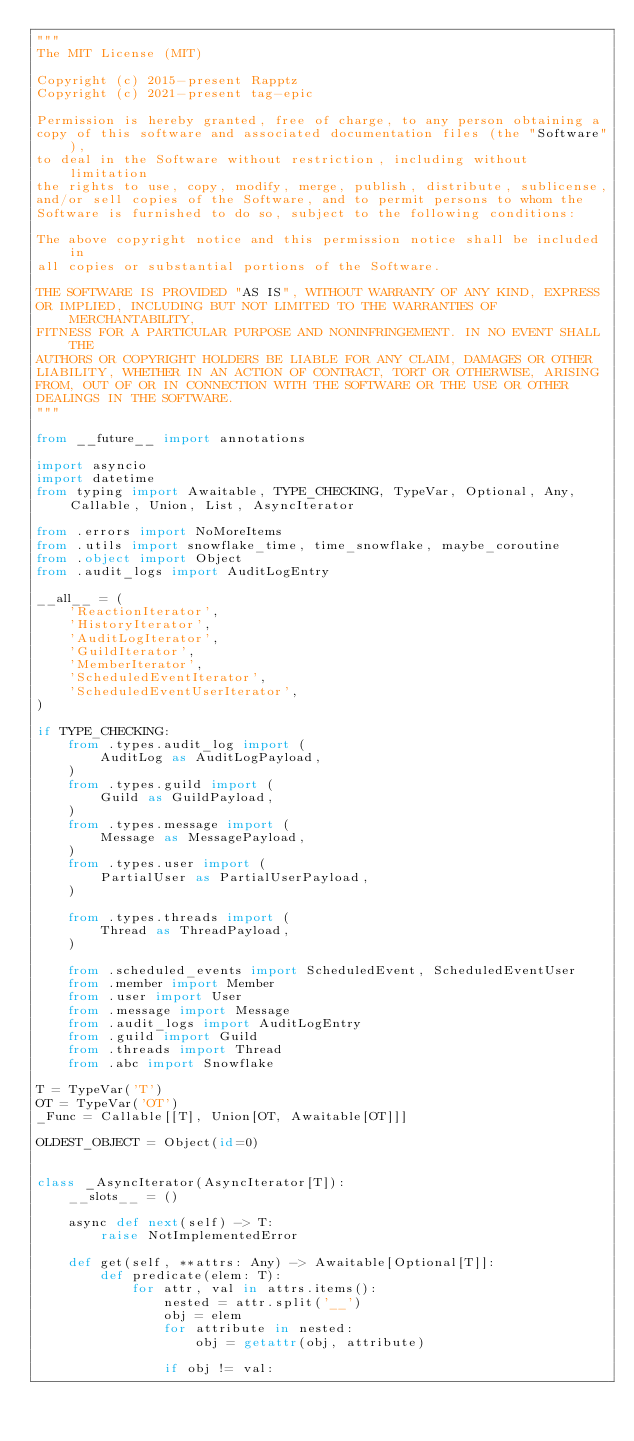<code> <loc_0><loc_0><loc_500><loc_500><_Python_>"""
The MIT License (MIT)

Copyright (c) 2015-present Rapptz
Copyright (c) 2021-present tag-epic

Permission is hereby granted, free of charge, to any person obtaining a
copy of this software and associated documentation files (the "Software"),
to deal in the Software without restriction, including without limitation
the rights to use, copy, modify, merge, publish, distribute, sublicense,
and/or sell copies of the Software, and to permit persons to whom the
Software is furnished to do so, subject to the following conditions:

The above copyright notice and this permission notice shall be included in
all copies or substantial portions of the Software.

THE SOFTWARE IS PROVIDED "AS IS", WITHOUT WARRANTY OF ANY KIND, EXPRESS
OR IMPLIED, INCLUDING BUT NOT LIMITED TO THE WARRANTIES OF MERCHANTABILITY,
FITNESS FOR A PARTICULAR PURPOSE AND NONINFRINGEMENT. IN NO EVENT SHALL THE
AUTHORS OR COPYRIGHT HOLDERS BE LIABLE FOR ANY CLAIM, DAMAGES OR OTHER
LIABILITY, WHETHER IN AN ACTION OF CONTRACT, TORT OR OTHERWISE, ARISING
FROM, OUT OF OR IN CONNECTION WITH THE SOFTWARE OR THE USE OR OTHER
DEALINGS IN THE SOFTWARE.
"""

from __future__ import annotations

import asyncio
import datetime
from typing import Awaitable, TYPE_CHECKING, TypeVar, Optional, Any, Callable, Union, List, AsyncIterator

from .errors import NoMoreItems
from .utils import snowflake_time, time_snowflake, maybe_coroutine
from .object import Object
from .audit_logs import AuditLogEntry

__all__ = (
    'ReactionIterator',
    'HistoryIterator',
    'AuditLogIterator',
    'GuildIterator',
    'MemberIterator',
    'ScheduledEventIterator',
    'ScheduledEventUserIterator',
)

if TYPE_CHECKING:
    from .types.audit_log import (
        AuditLog as AuditLogPayload,
    )
    from .types.guild import (
        Guild as GuildPayload,
    )
    from .types.message import (
        Message as MessagePayload,
    )
    from .types.user import (
        PartialUser as PartialUserPayload,
    )

    from .types.threads import (
        Thread as ThreadPayload,
    )

    from .scheduled_events import ScheduledEvent, ScheduledEventUser
    from .member import Member
    from .user import User
    from .message import Message
    from .audit_logs import AuditLogEntry
    from .guild import Guild
    from .threads import Thread
    from .abc import Snowflake

T = TypeVar('T')
OT = TypeVar('OT')
_Func = Callable[[T], Union[OT, Awaitable[OT]]]

OLDEST_OBJECT = Object(id=0)


class _AsyncIterator(AsyncIterator[T]):
    __slots__ = ()

    async def next(self) -> T:
        raise NotImplementedError

    def get(self, **attrs: Any) -> Awaitable[Optional[T]]:
        def predicate(elem: T):
            for attr, val in attrs.items():
                nested = attr.split('__')
                obj = elem
                for attribute in nested:
                    obj = getattr(obj, attribute)

                if obj != val:</code> 